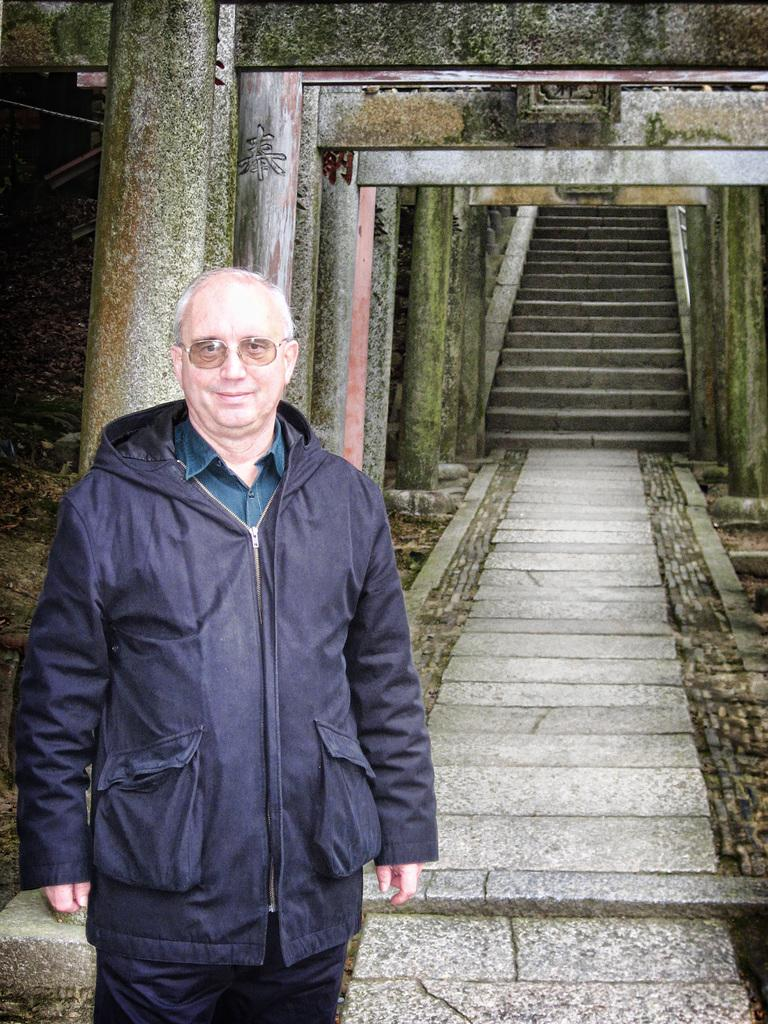Who is the main subject in the image? There is an old man in the image. What is the old man wearing? The old man is wearing a navy blue jacket. Where is the old man positioned in the image? The old man is standing on the left side of the image. What can be seen behind the old man? There is a path behind the old man, followed by steps. What type of structure might be depicted in the image? The image appears to depict an ancient building. What type of comb does the old man use to style his hair in the image? There is no comb visible in the image, and it is not possible to determine how the old man styles his hair. 